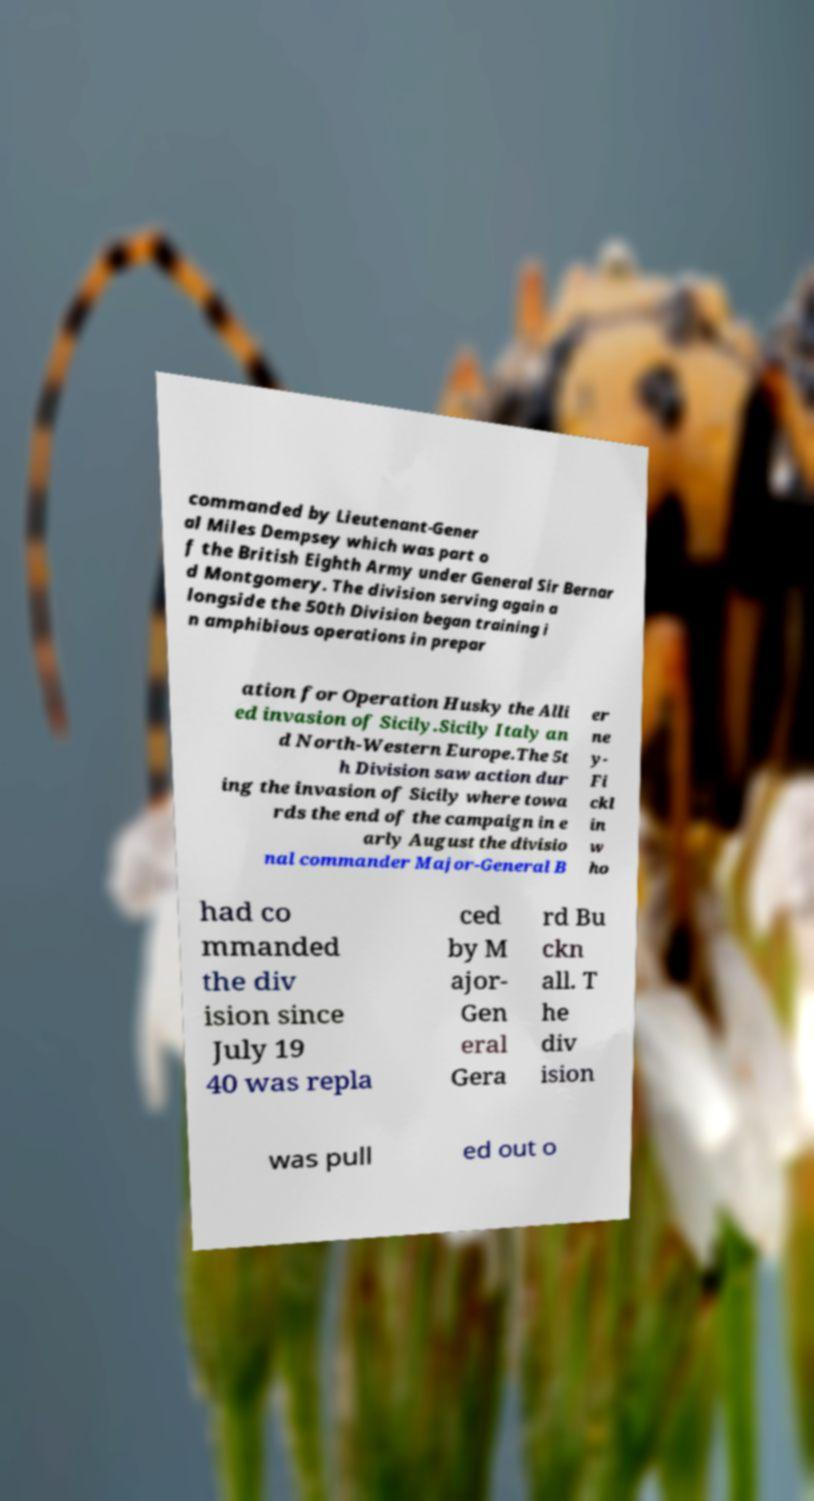I need the written content from this picture converted into text. Can you do that? commanded by Lieutenant-Gener al Miles Dempsey which was part o f the British Eighth Army under General Sir Bernar d Montgomery. The division serving again a longside the 50th Division began training i n amphibious operations in prepar ation for Operation Husky the Alli ed invasion of Sicily.Sicily Italy an d North-Western Europe.The 5t h Division saw action dur ing the invasion of Sicily where towa rds the end of the campaign in e arly August the divisio nal commander Major-General B er ne y- Fi ckl in w ho had co mmanded the div ision since July 19 40 was repla ced by M ajor- Gen eral Gera rd Bu ckn all. T he div ision was pull ed out o 